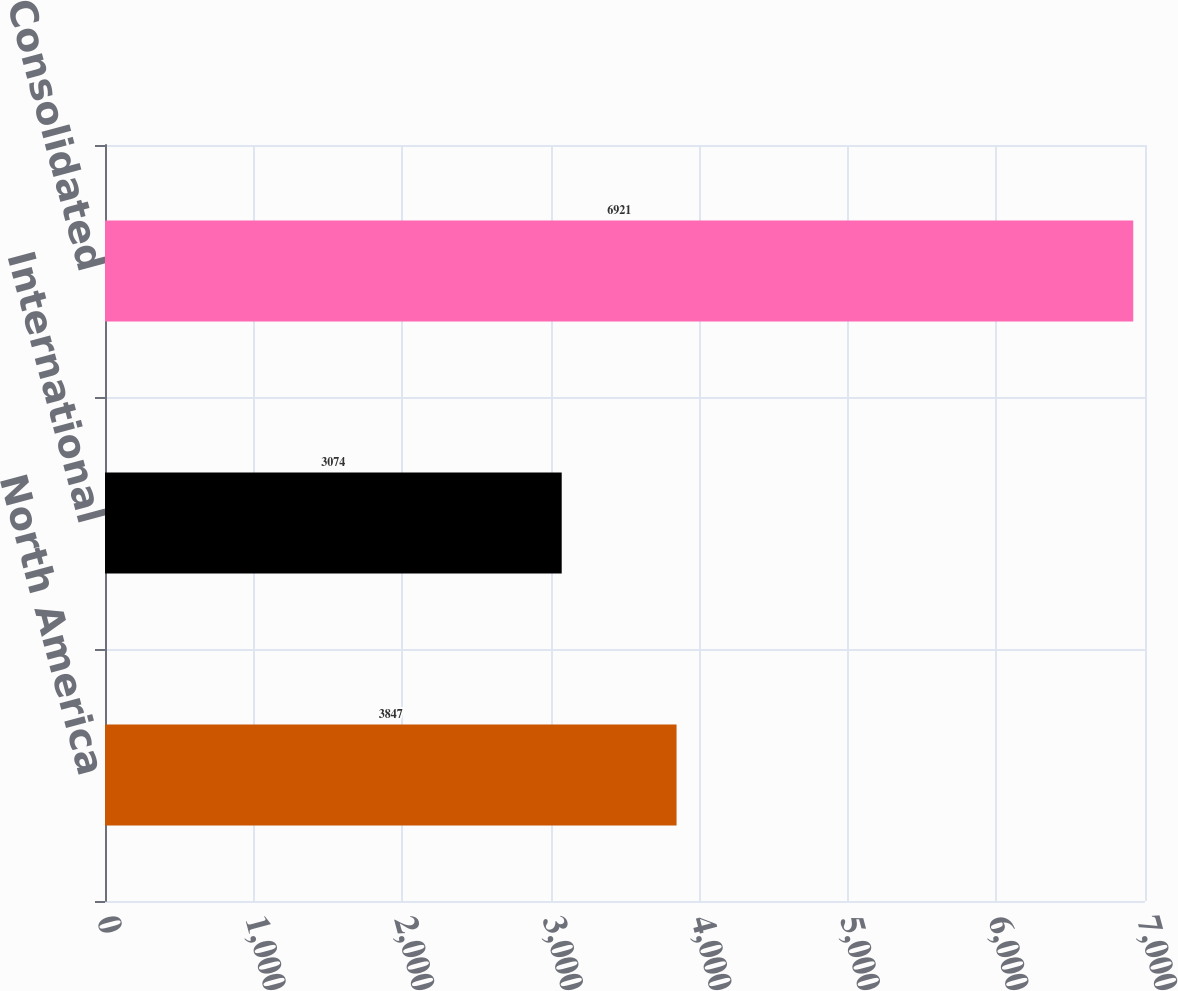Convert chart to OTSL. <chart><loc_0><loc_0><loc_500><loc_500><bar_chart><fcel>North America<fcel>International<fcel>Consolidated<nl><fcel>3847<fcel>3074<fcel>6921<nl></chart> 